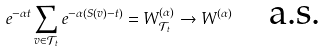<formula> <loc_0><loc_0><loc_500><loc_500>e ^ { - \alpha t } \sum _ { v \in \mathcal { T } _ { t } } e ^ { - \alpha ( S ( v ) - t ) } = W ^ { ( \alpha ) } _ { \mathcal { T } _ { t } } \to W ^ { ( \alpha ) } \quad \text {a.s.}</formula> 